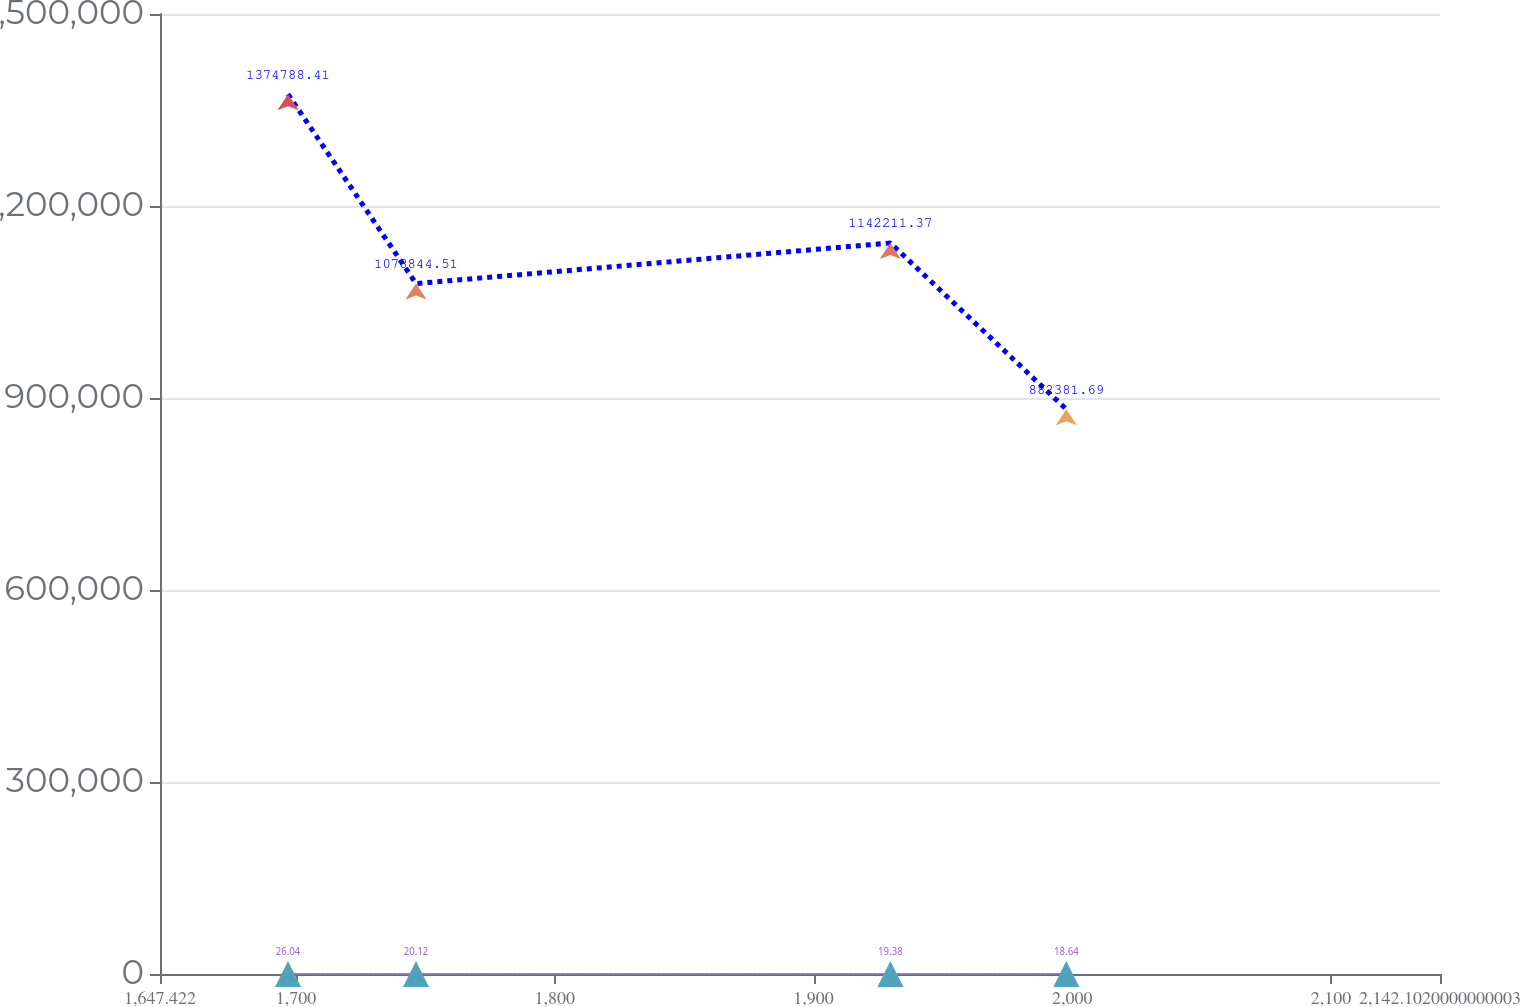Convert chart to OTSL. <chart><loc_0><loc_0><loc_500><loc_500><line_chart><ecel><fcel>Rentable  Square Feet<fcel>Occupancy Rate<fcel>Weighted Average Annual  Rent Per  Square Foot<nl><fcel>1696.89<fcel>1.37479e+06<fcel>81.81<fcel>26.04<nl><fcel>1746.36<fcel>1.07884e+06<fcel>97.22<fcel>20.12<nl><fcel>1929.68<fcel>1.14221e+06<fcel>95.39<fcel>19.38<nl><fcel>1997.69<fcel>882382<fcel>77.86<fcel>18.64<nl><fcel>2191.57<fcel>931622<fcel>79.69<fcel>21.07<nl></chart> 